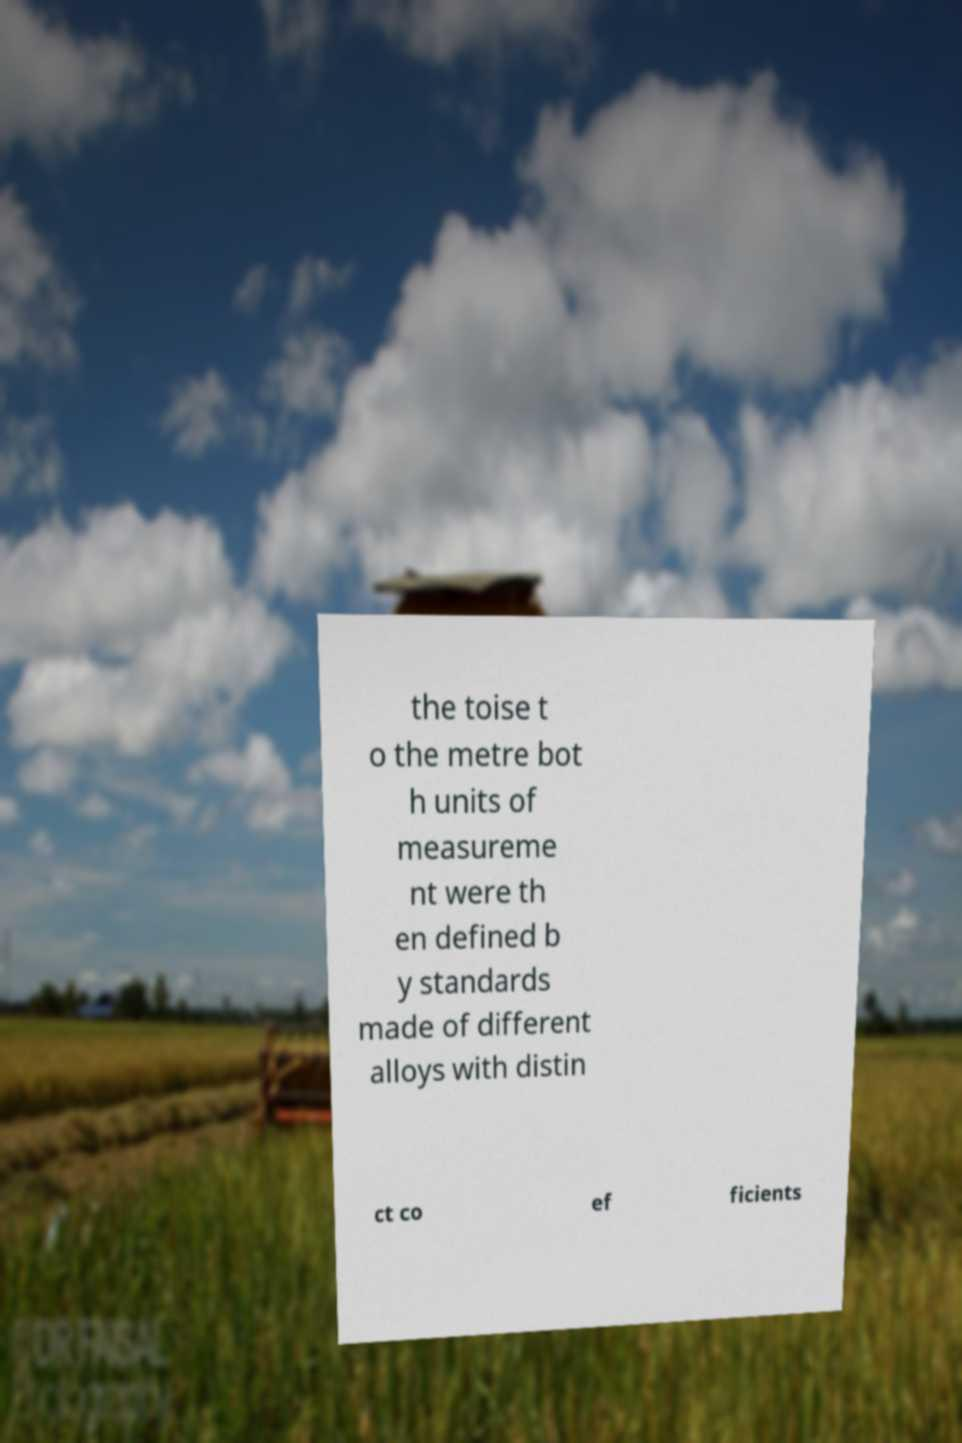There's text embedded in this image that I need extracted. Can you transcribe it verbatim? the toise t o the metre bot h units of measureme nt were th en defined b y standards made of different alloys with distin ct co ef ficients 